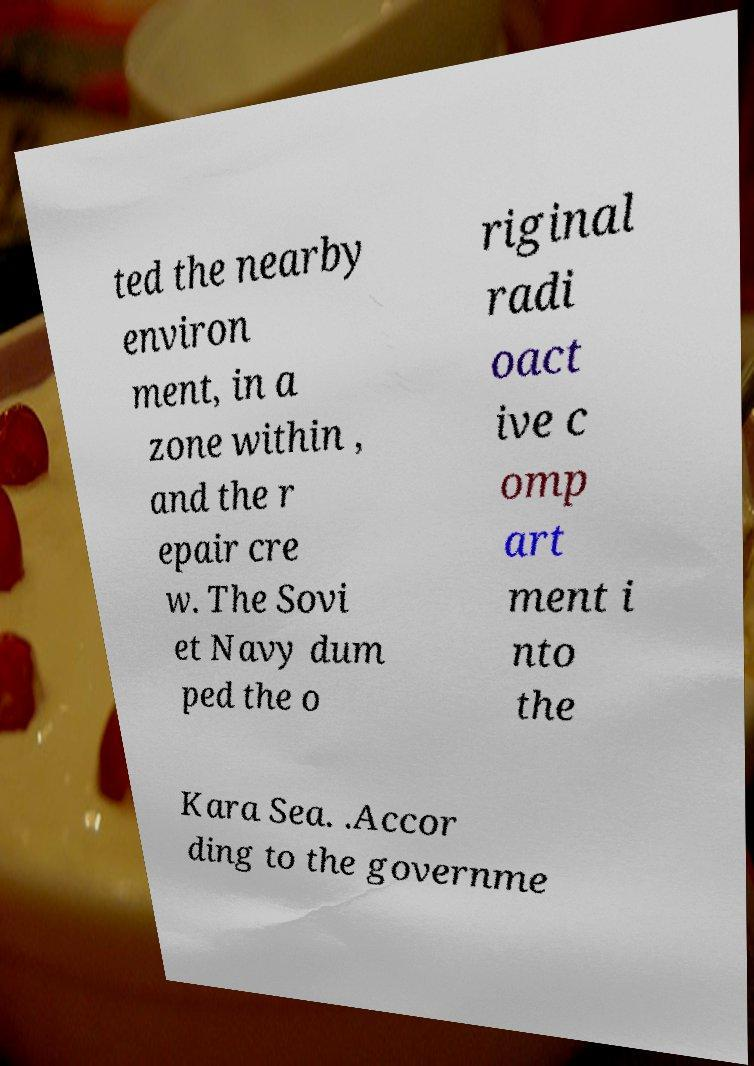Could you extract and type out the text from this image? ted the nearby environ ment, in a zone within , and the r epair cre w. The Sovi et Navy dum ped the o riginal radi oact ive c omp art ment i nto the Kara Sea. .Accor ding to the governme 